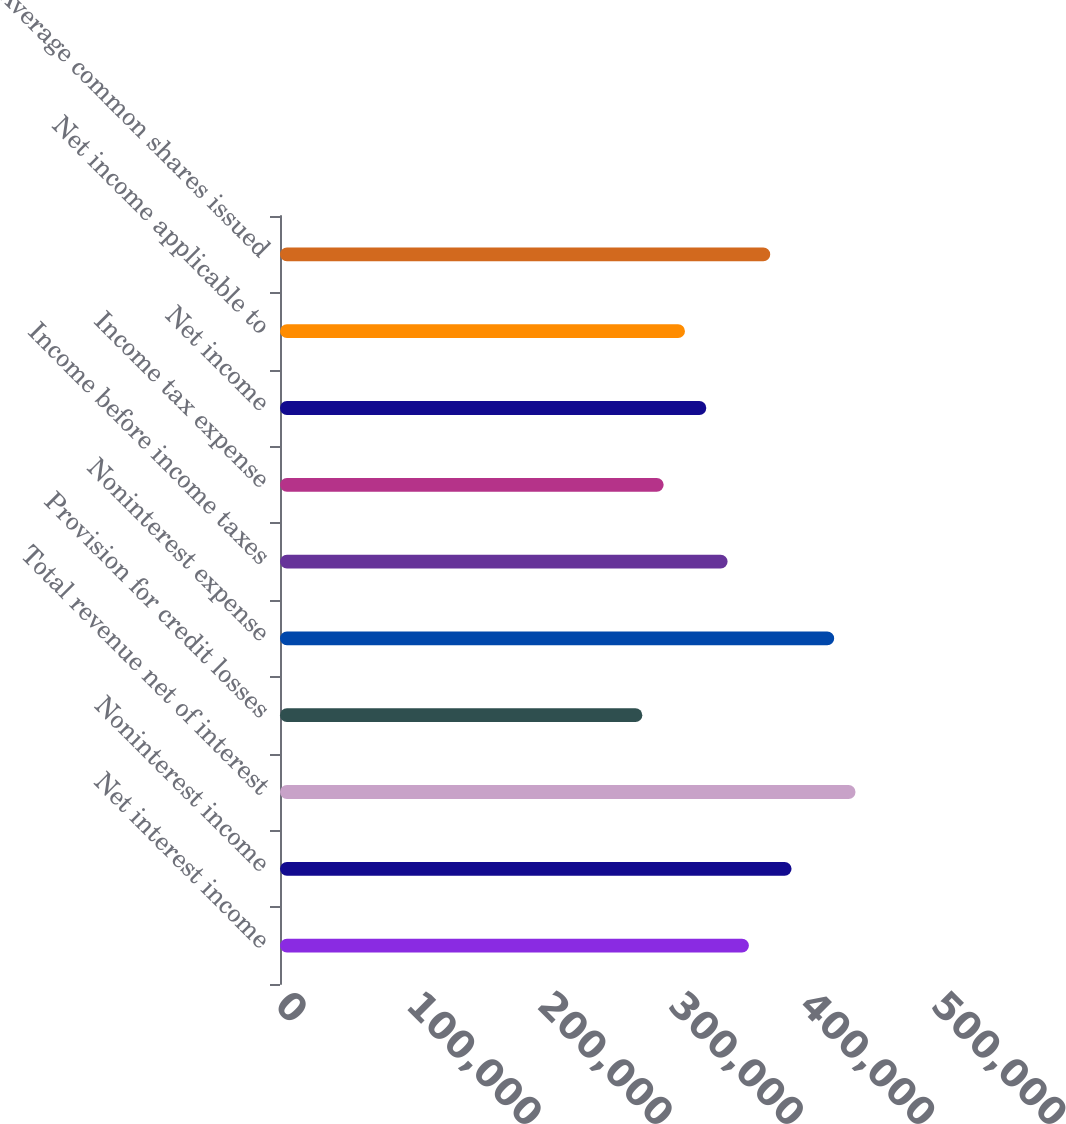Convert chart. <chart><loc_0><loc_0><loc_500><loc_500><bar_chart><fcel>Net interest income<fcel>Noninterest income<fcel>Total revenue net of interest<fcel>Provision for credit losses<fcel>Noninterest expense<fcel>Income before income taxes<fcel>Income tax expense<fcel>Net income<fcel>Net income applicable to<fcel>Average common shares issued<nl><fcel>357405<fcel>389897<fcel>438634<fcel>276177<fcel>422388<fcel>341160<fcel>292423<fcel>324914<fcel>308668<fcel>373651<nl></chart> 